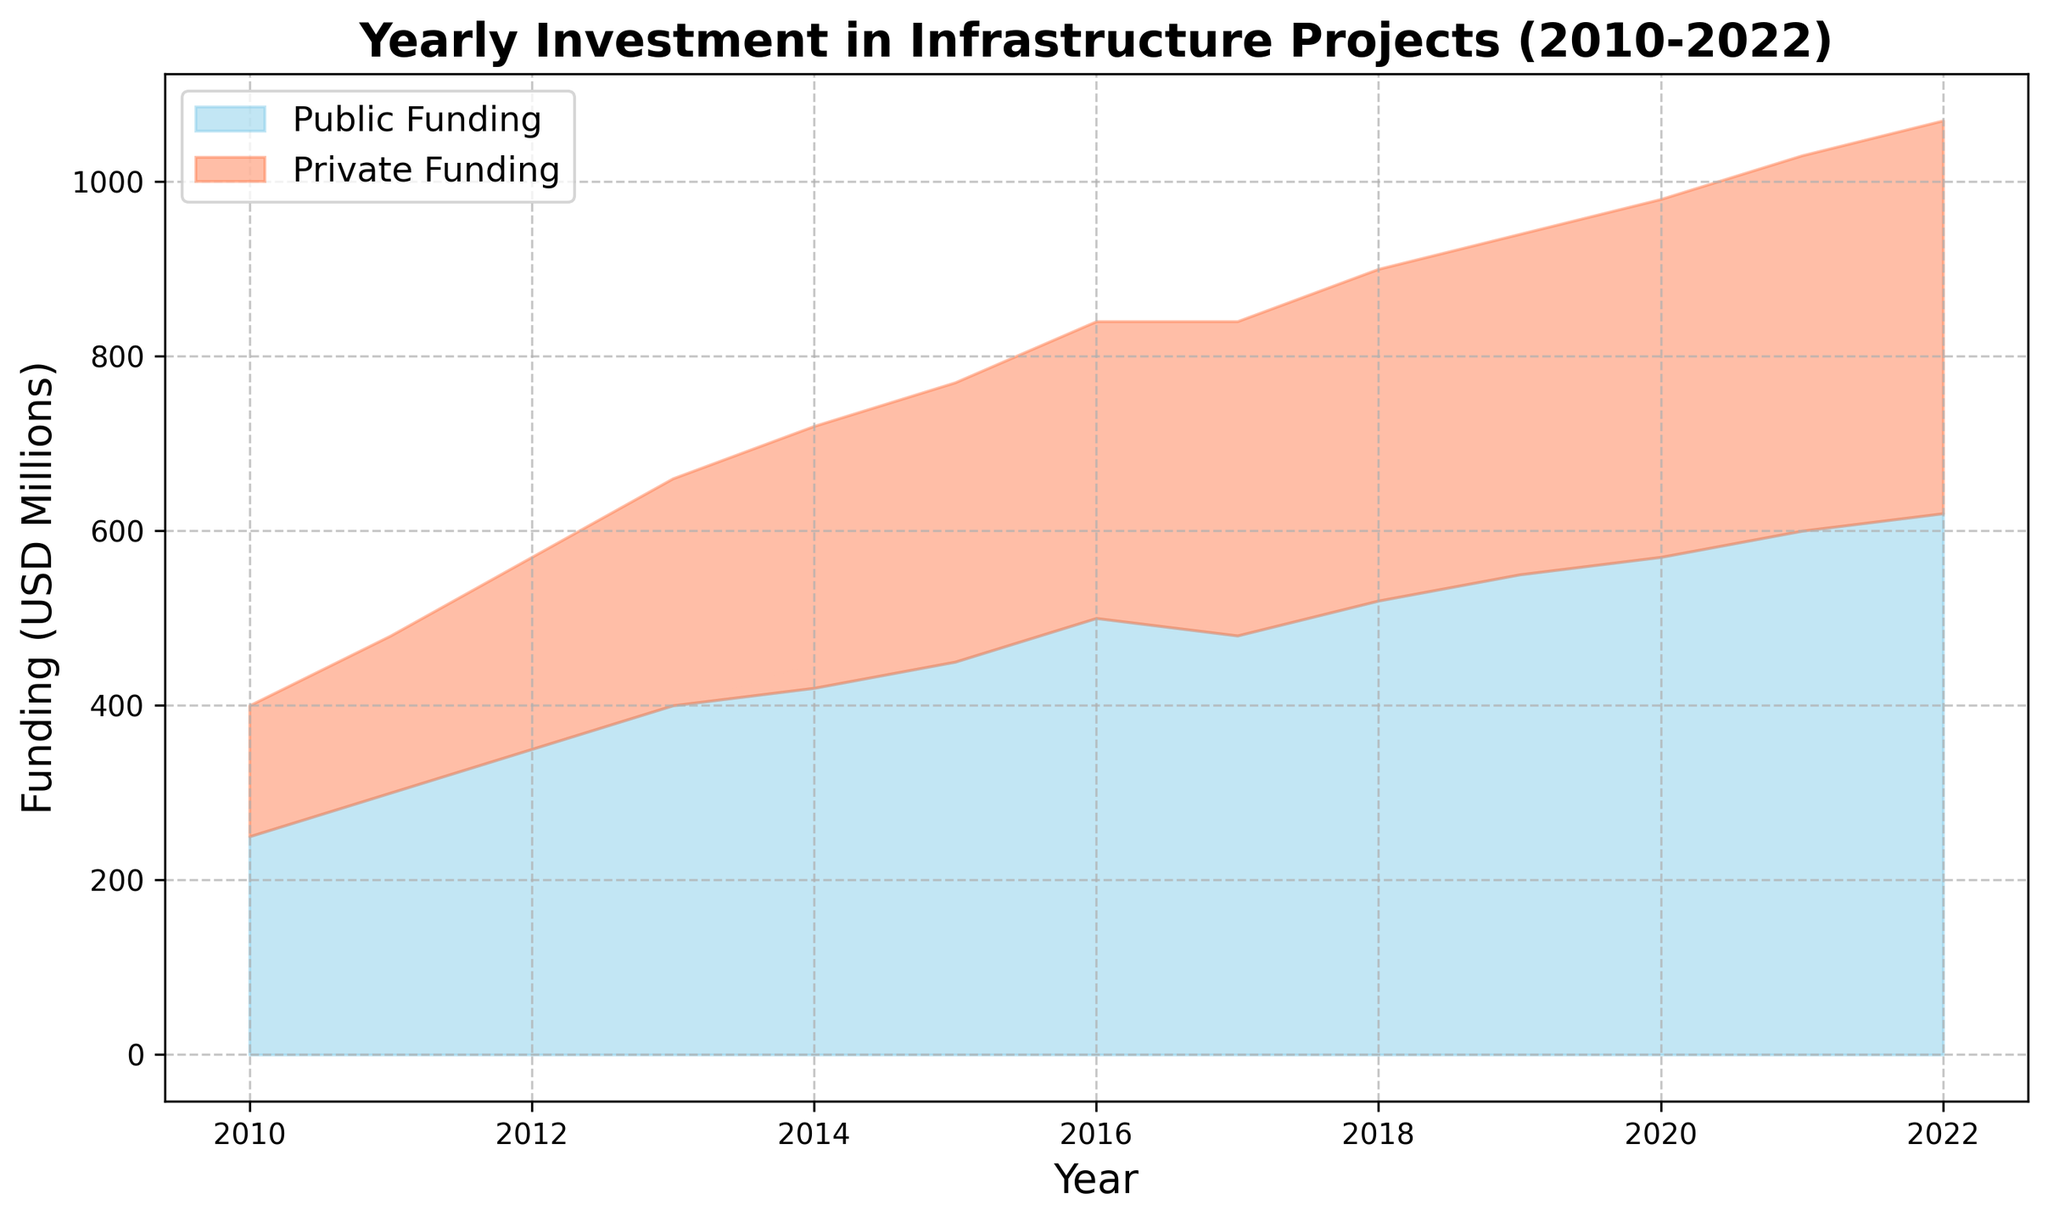How much was the total investment in infrastructure projects in 2010? The total investment is the sum of public funding and private funding for the year 2010, which is 250 million USD (public) + 150 million USD (private).
Answer: 400 million USD What is the trend for public funding from 2010 to 2022? The public funding shows an increasing trend from 250 million USD in 2010 to 620 million USD in 2022 with some fluctuations in between.
Answer: Increasing trend How did private funding compare to public funding in 2017? In 2017, public funding was 480 million USD, and private funding was 360 million USD. Public funding was greater than private funding.
Answer: Public funding was higher What is the average annual private funding over the period 2010-2022? Sum the private funding from 2010-2022 and divide by the number of years. Total private funding is 150 + 180 + 220 + 260 + 300 + 320 + 340 + 360 + 380 + 390 + 410 + 430 + 450 = 4190 million USD. Number of years is 13. Average = 4190 / 13.
Answer: 322 million USD In which year did the public funding witness the highest increase compared to the previous year? Calculate the difference year-on-year for public funding: 
2011 vs 2010: 300 - 250 = 50 
2012 vs 2011: 350 - 300 = 50 
2013 vs 2012: 400 - 350 = 50 
2014 vs 2013: 420 - 400 = 20 
2015 vs 2014: 450 - 420 = 30 
2016 vs 2015: 500 - 450 = 50 
2017 vs 2016: 480 - 500 = -20 
2018 vs 2017: 520 - 480 = 40 
2019 vs 2018: 550 - 520 = 30 
2020 vs 2019: 570 - 550 = 20 
2021 vs 2020: 600 - 570 = 30 
2022 vs 2021: 620 - 600 = 20
Answer: 2011, 2012, and 2016 with 50 million USD increase Which year had the highest total investment in infrastructure projects? Total investment is the sum of public and private funding. In 2022, public funding is 620 million USD and private funding is 450 million USD. Total is 1070 million USD, which is the highest.
Answer: 2022 What portion of the total investment in 2015 was from private funding? Total investment in 2015 is 450 million USD (public) + 320 million USD (private) = 770 million USD. The portion from private funding is 320 / 770 ≈ 0.4156.
Answer: Approximately 0.416 or 41.6% Did private funding ever surpass public funding in any year? By comparing public and private funding year by year from 2010 to 2022, it's seen that private funding never surpassed public funding.
Answer: No What is the difference in public funding between the year with the highest amount and the year with the lowest amount? The highest public funding is in 2022 with 620 million USD, and the lowest is in 2010 with 250 million USD. The difference is 620 - 250 = 370 million USD.
Answer: 370 million USD 